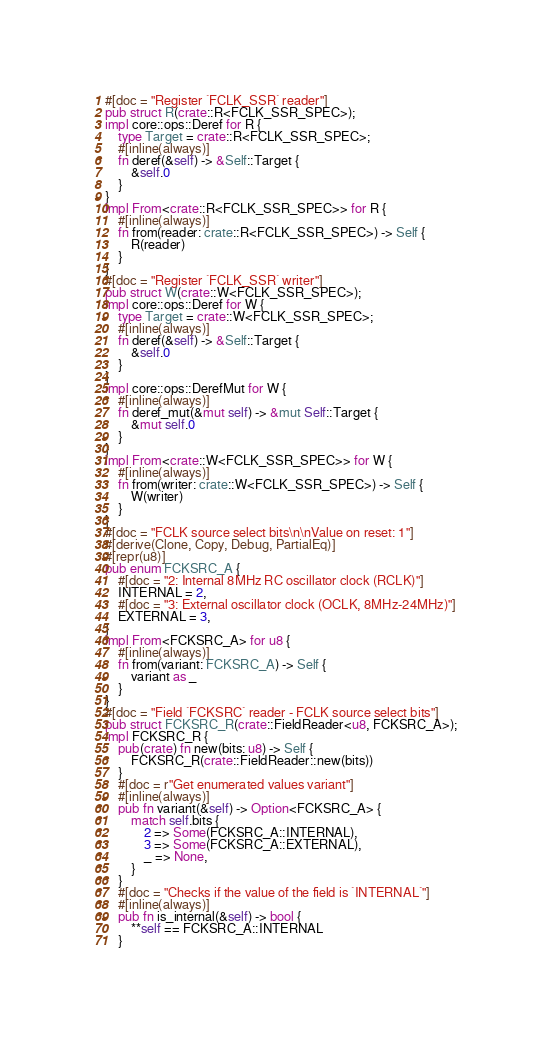<code> <loc_0><loc_0><loc_500><loc_500><_Rust_>#[doc = "Register `FCLK_SSR` reader"]
pub struct R(crate::R<FCLK_SSR_SPEC>);
impl core::ops::Deref for R {
    type Target = crate::R<FCLK_SSR_SPEC>;
    #[inline(always)]
    fn deref(&self) -> &Self::Target {
        &self.0
    }
}
impl From<crate::R<FCLK_SSR_SPEC>> for R {
    #[inline(always)]
    fn from(reader: crate::R<FCLK_SSR_SPEC>) -> Self {
        R(reader)
    }
}
#[doc = "Register `FCLK_SSR` writer"]
pub struct W(crate::W<FCLK_SSR_SPEC>);
impl core::ops::Deref for W {
    type Target = crate::W<FCLK_SSR_SPEC>;
    #[inline(always)]
    fn deref(&self) -> &Self::Target {
        &self.0
    }
}
impl core::ops::DerefMut for W {
    #[inline(always)]
    fn deref_mut(&mut self) -> &mut Self::Target {
        &mut self.0
    }
}
impl From<crate::W<FCLK_SSR_SPEC>> for W {
    #[inline(always)]
    fn from(writer: crate::W<FCLK_SSR_SPEC>) -> Self {
        W(writer)
    }
}
#[doc = "FCLK source select bits\n\nValue on reset: 1"]
#[derive(Clone, Copy, Debug, PartialEq)]
#[repr(u8)]
pub enum FCKSRC_A {
    #[doc = "2: Internal 8MHz RC oscillator clock (RCLK)"]
    INTERNAL = 2,
    #[doc = "3: External oscillator clock (OCLK, 8MHz-24MHz)"]
    EXTERNAL = 3,
}
impl From<FCKSRC_A> for u8 {
    #[inline(always)]
    fn from(variant: FCKSRC_A) -> Self {
        variant as _
    }
}
#[doc = "Field `FCKSRC` reader - FCLK source select bits"]
pub struct FCKSRC_R(crate::FieldReader<u8, FCKSRC_A>);
impl FCKSRC_R {
    pub(crate) fn new(bits: u8) -> Self {
        FCKSRC_R(crate::FieldReader::new(bits))
    }
    #[doc = r"Get enumerated values variant"]
    #[inline(always)]
    pub fn variant(&self) -> Option<FCKSRC_A> {
        match self.bits {
            2 => Some(FCKSRC_A::INTERNAL),
            3 => Some(FCKSRC_A::EXTERNAL),
            _ => None,
        }
    }
    #[doc = "Checks if the value of the field is `INTERNAL`"]
    #[inline(always)]
    pub fn is_internal(&self) -> bool {
        **self == FCKSRC_A::INTERNAL
    }</code> 